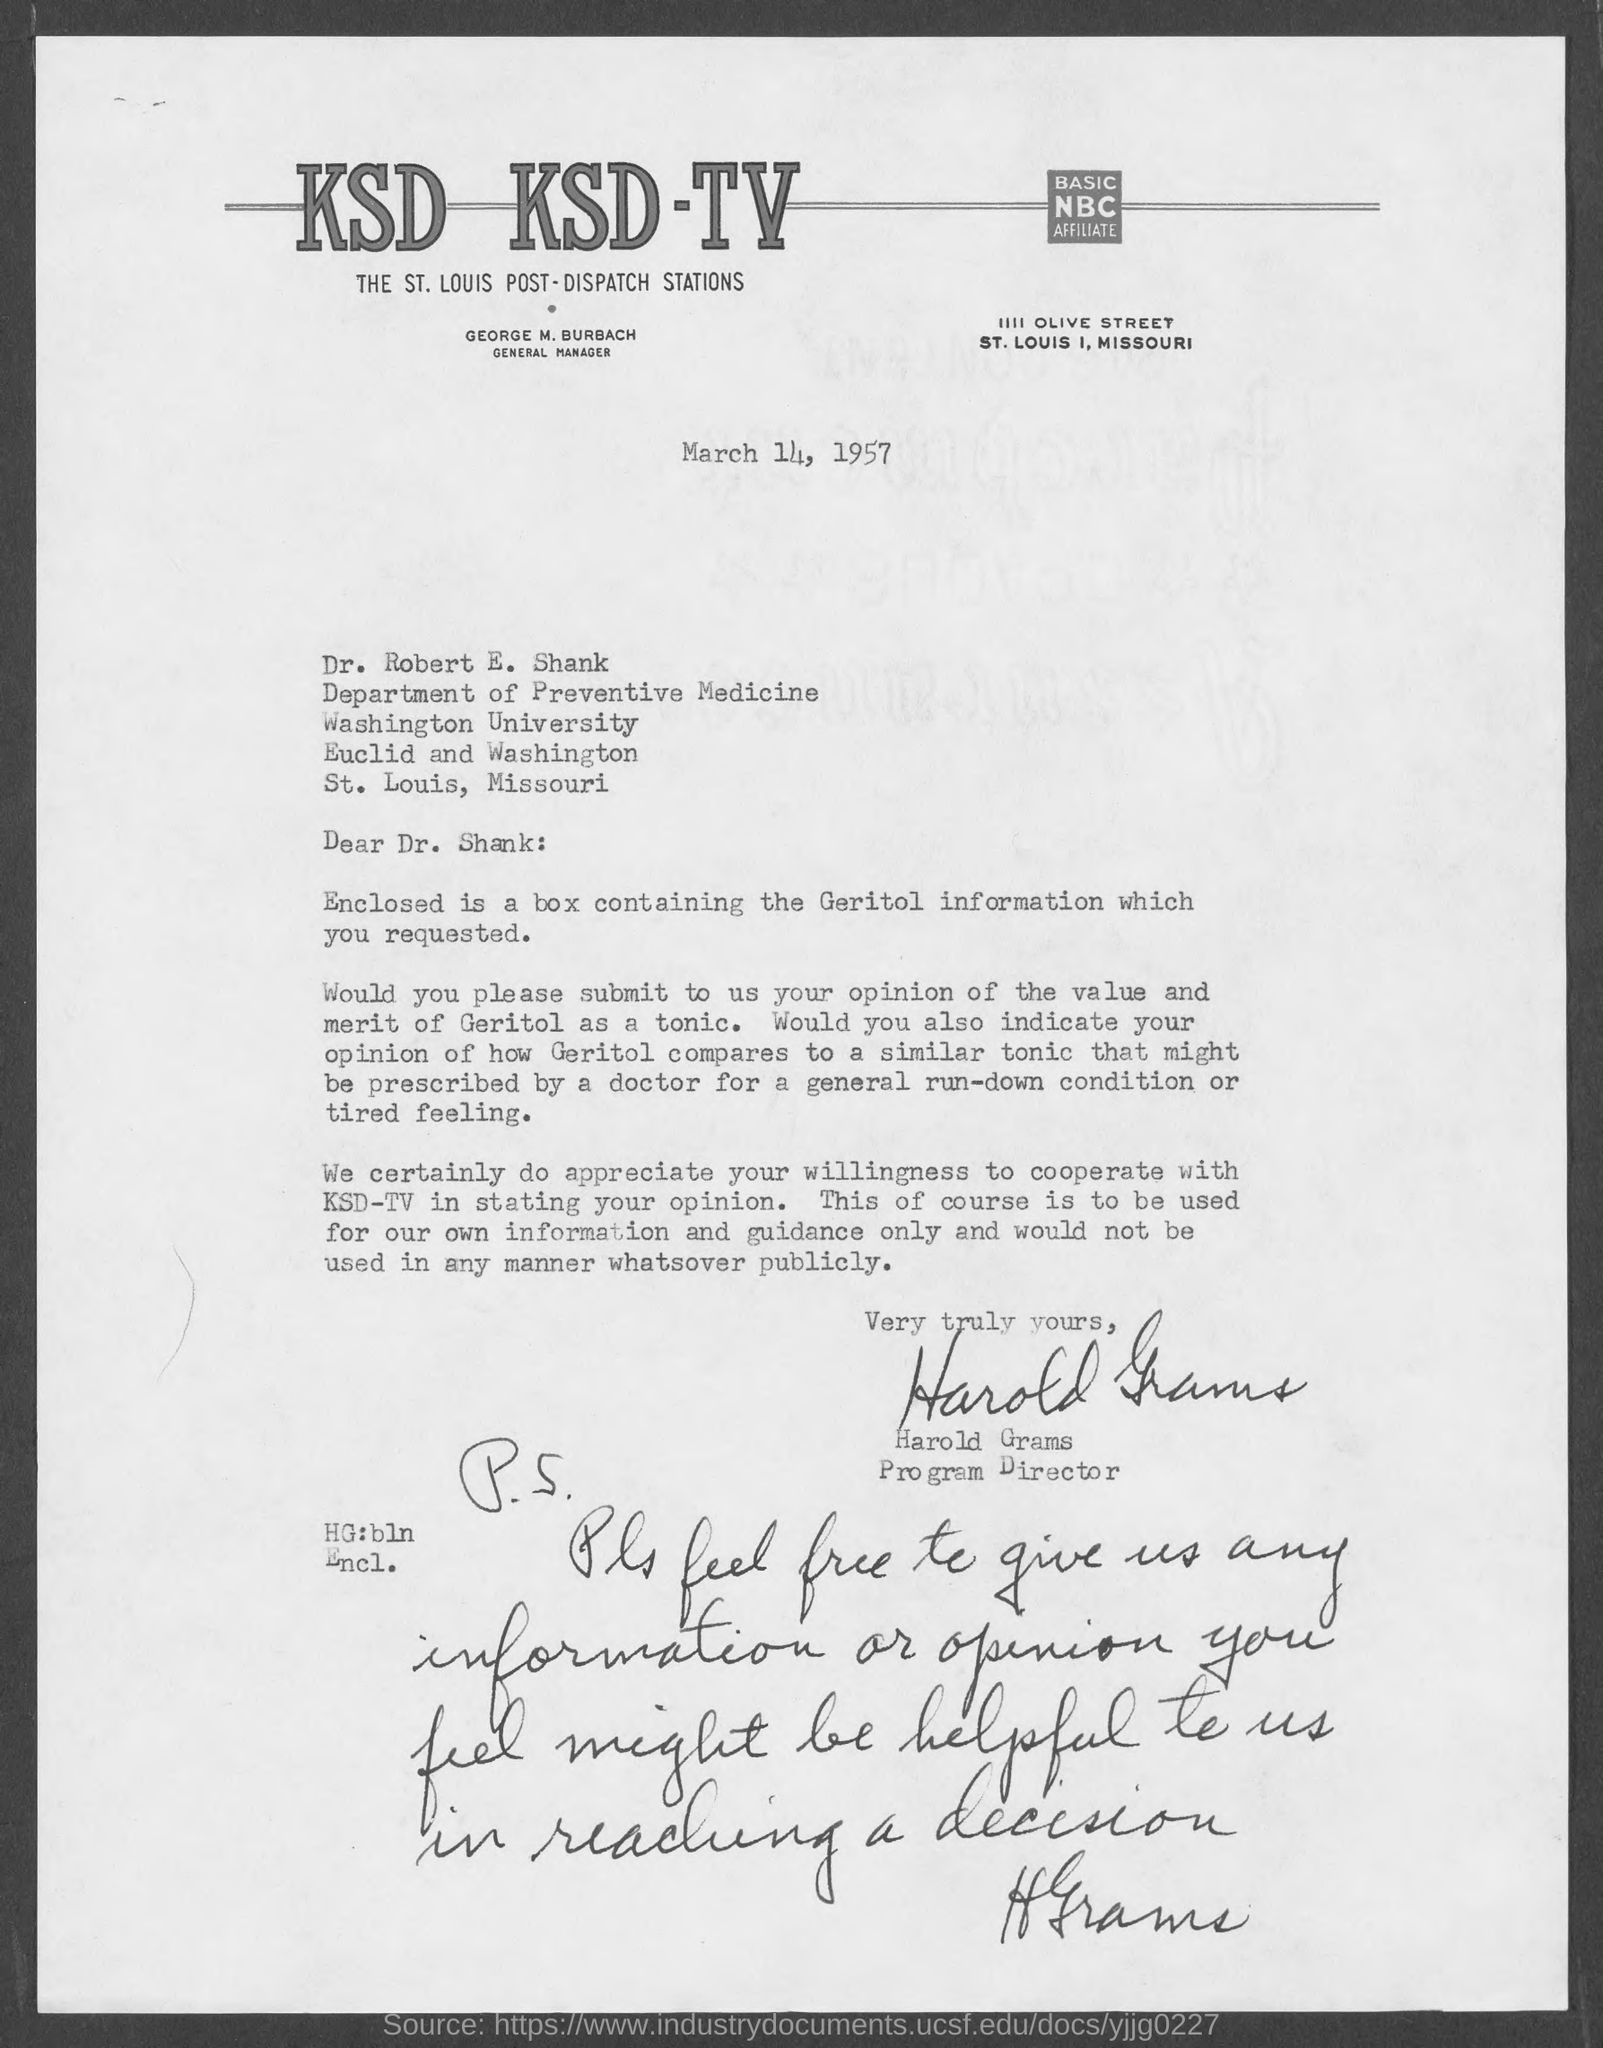Who is the general manager ksd ksd-tv?
Make the answer very short. GEORGE M. BURBACH. To whom this letter is written to?
Offer a terse response. Dr. Robert E. Shank. Who is the program director ?
Your answer should be very brief. Harold Grams. To which department does Dr.Robert E. Shank belong to?
Your response must be concise. DEPARTMENT OF PREVENTIVE MEDICINE. What is enclosed along with the letter?
Make the answer very short. Box containing Geritol Information. 